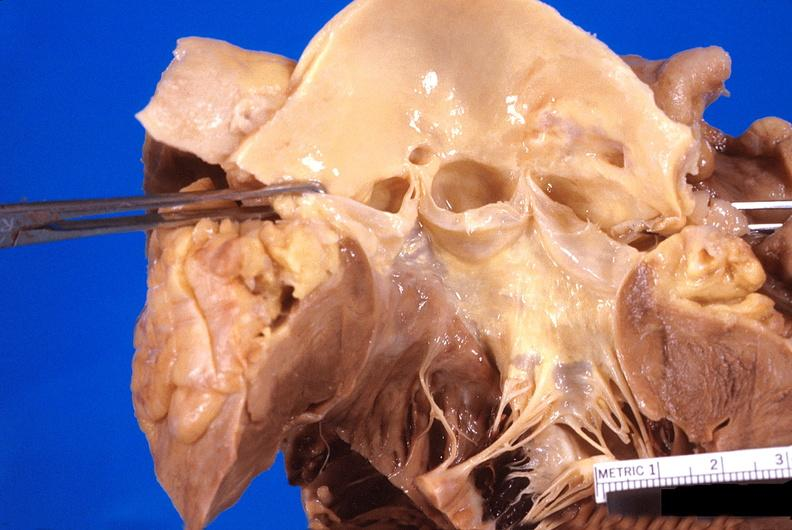what is present?
Answer the question using a single word or phrase. Heart 